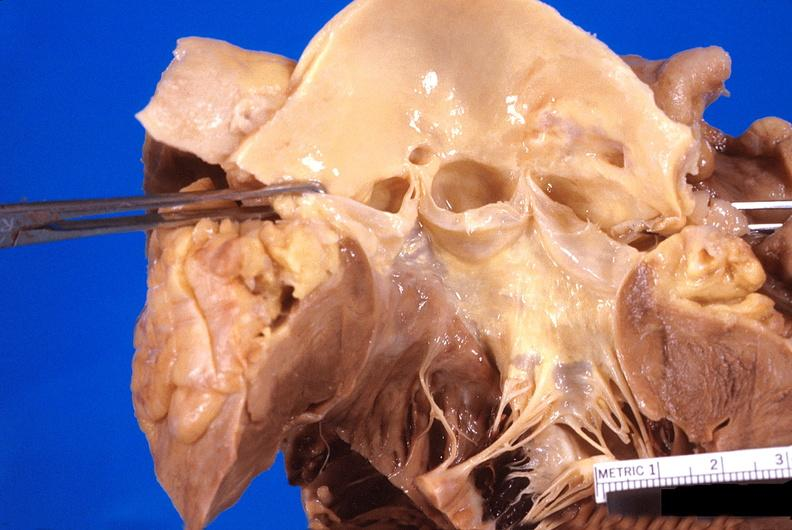what is present?
Answer the question using a single word or phrase. Heart 